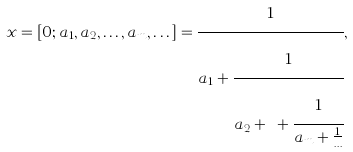Convert formula to latex. <formula><loc_0><loc_0><loc_500><loc_500>x = [ 0 ; a _ { 1 } , a _ { 2 } , \dots , a _ { m } , \dots ] = \cfrac { 1 } { a _ { 1 } + \cfrac { 1 } { a _ { 2 } + \dots + \cfrac { 1 } { a _ { m } + \frac { 1 } { \dots } } } } ,</formula> 